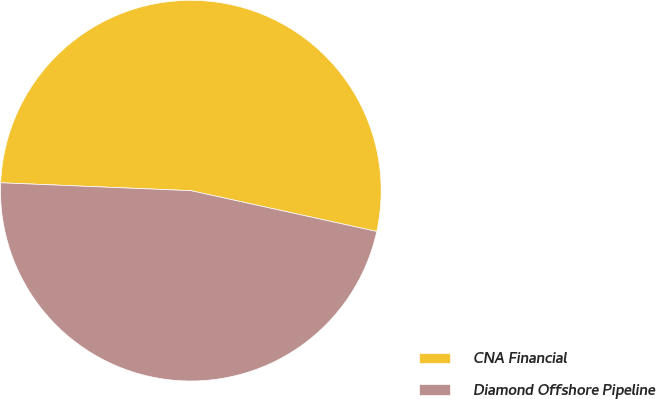<chart> <loc_0><loc_0><loc_500><loc_500><pie_chart><fcel>CNA Financial<fcel>Diamond Offshore Pipeline<nl><fcel>52.78%<fcel>47.22%<nl></chart> 